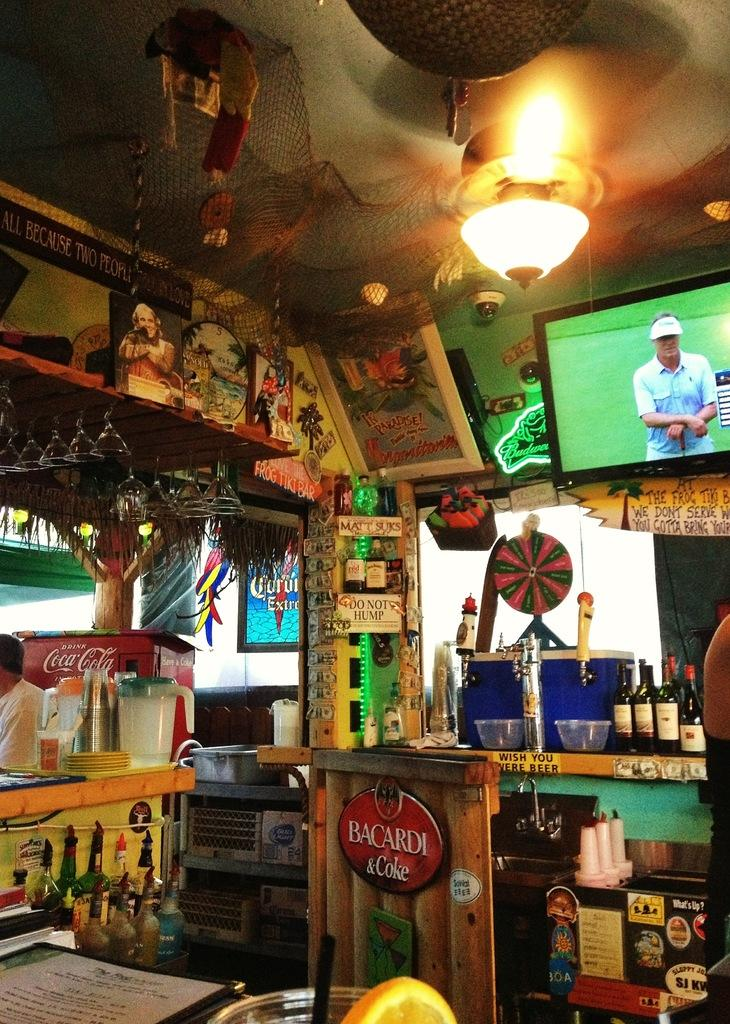What type of items can be seen on the walls in the image? There are posters with images and text in the image. What type of items are used for displaying photos in the image? There are photo frames in the image. What type of items can be seen for holding liquids in the image? There are bottles and glasses in the image. What type of light source is visible in the image? There is a light in the image. What type of storage items can be seen in the image? There are boxes and a fridge in the image. What type of items can be seen for holding food in the image? There are bowls in the image. What type of items can be seen for writing or reading in the image? There are papers in the image. What type of architectural feature is visible in the image? There are windows in the image. What type of crook can be seen in the image? There is no crook present in the image. What type of club can be seen in the image? There is no club present in the image. 